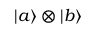<formula> <loc_0><loc_0><loc_500><loc_500>\left | a \right \rangle \otimes \left | b \right \rangle</formula> 